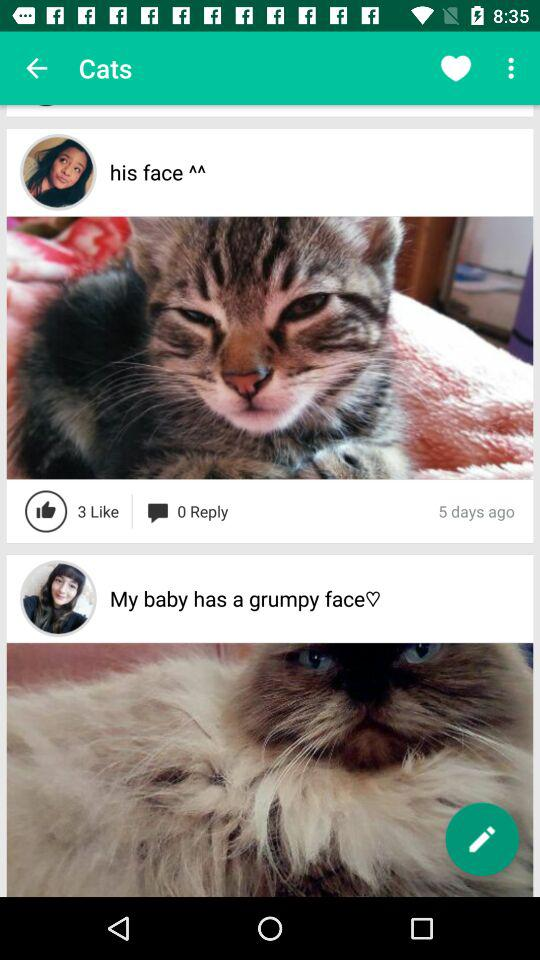How many likes are there? There are 3 likes. 